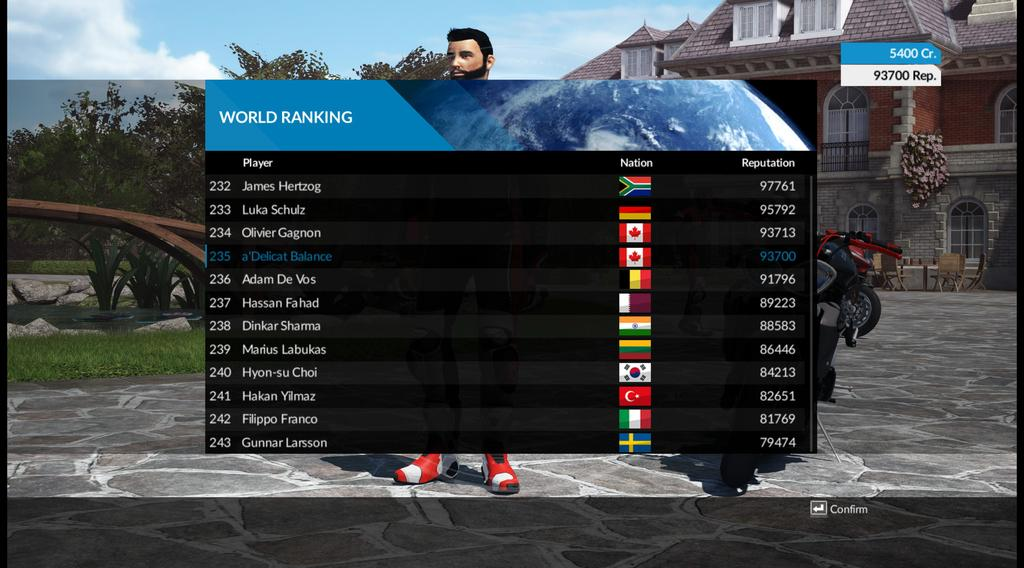<image>
Summarize the visual content of the image. A world ranking of players in a video game. 